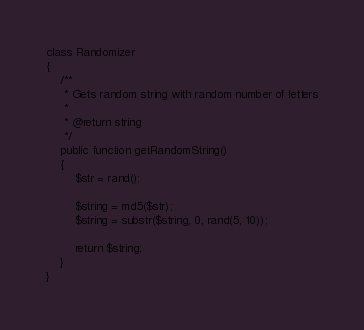Convert code to text. <code><loc_0><loc_0><loc_500><loc_500><_PHP_>class Randomizer
{
    /**
     * Gets random string with random number of letters
     *
     * @return string
     */
    public function getRandomString()
    {
        $str = rand();

        $string = md5($str);
        $string = substr($string, 0, rand(5, 10));

        return $string;
    }
}
</code> 